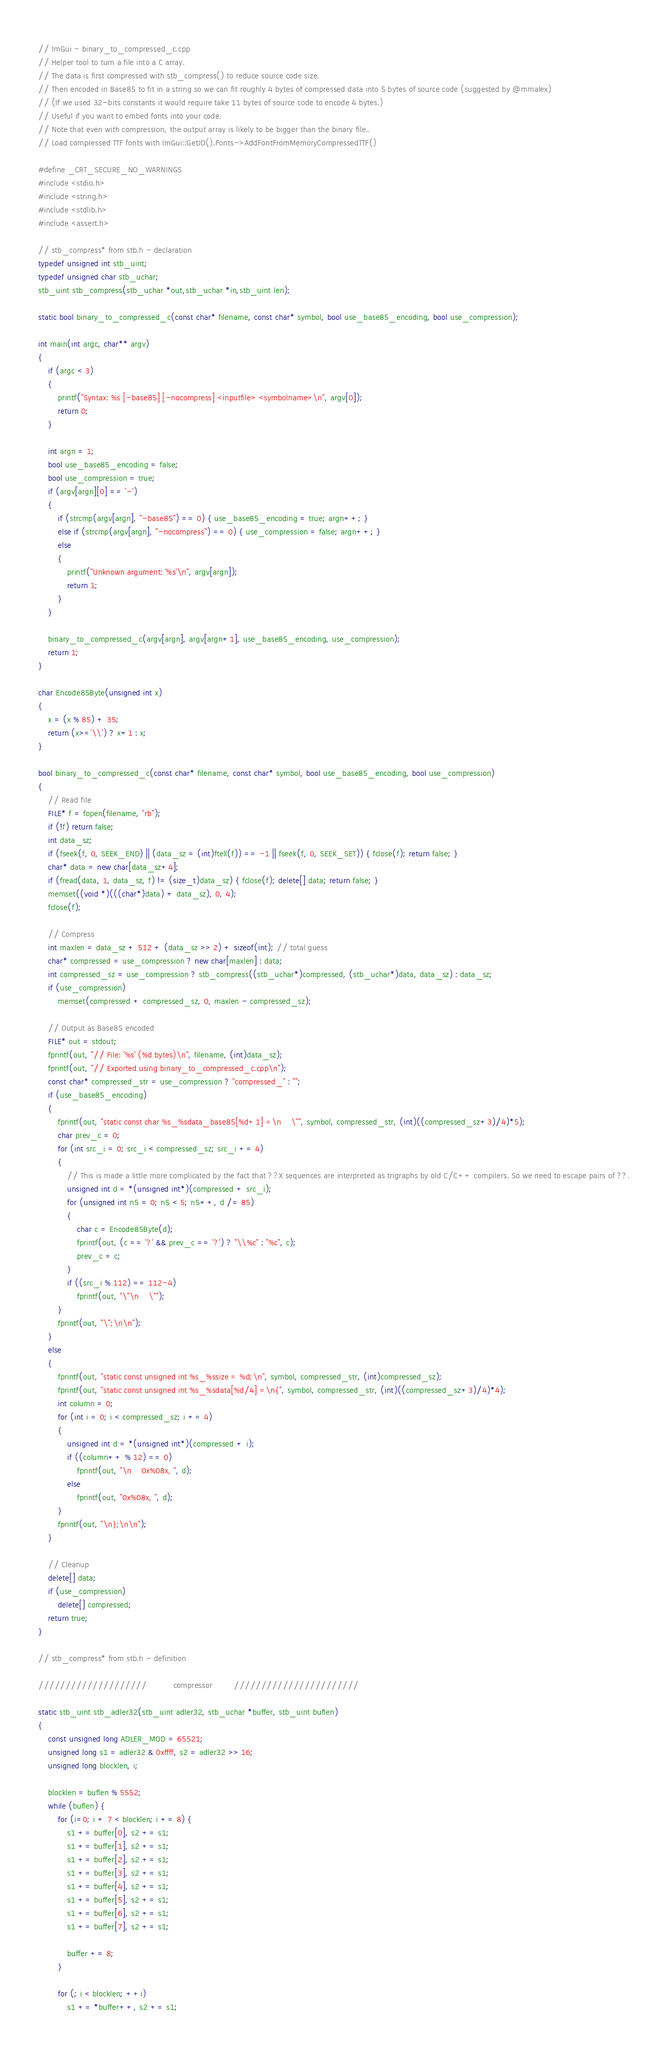Convert code to text. <code><loc_0><loc_0><loc_500><loc_500><_C++_>// ImGui - binary_to_compressed_c.cpp
// Helper tool to turn a file into a C array.
// The data is first compressed with stb_compress() to reduce source code size.
// Then encoded in Base85 to fit in a string so we can fit roughly 4 bytes of compressed data into 5 bytes of source code (suggested by @mmalex)
// (If we used 32-bits constants it would require take 11 bytes of source code to encode 4 bytes.)
// Useful if you want to embed fonts into your code.
// Note that even with compression, the output array is likely to be bigger than the binary file..
// Load compressed TTF fonts with ImGui::GetIO().Fonts->AddFontFromMemoryCompressedTTF()

#define _CRT_SECURE_NO_WARNINGS
#include <stdio.h>
#include <string.h>
#include <stdlib.h>
#include <assert.h>

// stb_compress* from stb.h - declaration
typedef unsigned int stb_uint;
typedef unsigned char stb_uchar;
stb_uint stb_compress(stb_uchar *out,stb_uchar *in,stb_uint len);

static bool binary_to_compressed_c(const char* filename, const char* symbol, bool use_base85_encoding, bool use_compression);

int main(int argc, char** argv)
{
    if (argc < 3)
    {
        printf("Syntax: %s [-base85] [-nocompress] <inputfile> <symbolname>\n", argv[0]);
        return 0;
    }

    int argn = 1;
    bool use_base85_encoding = false;
    bool use_compression = true;
    if (argv[argn][0] == '-')
    {
        if (strcmp(argv[argn], "-base85") == 0) { use_base85_encoding = true; argn++; }
        else if (strcmp(argv[argn], "-nocompress") == 0) { use_compression = false; argn++; }
        else
        {
            printf("Unknown argument: '%s'\n", argv[argn]);
            return 1;
        }
    }

    binary_to_compressed_c(argv[argn], argv[argn+1], use_base85_encoding, use_compression);
    return 1;
}

char Encode85Byte(unsigned int x) 
{
    x = (x % 85) + 35;
    return (x>='\\') ? x+1 : x;
}

bool binary_to_compressed_c(const char* filename, const char* symbol, bool use_base85_encoding, bool use_compression)
{
    // Read file
    FILE* f = fopen(filename, "rb");
    if (!f) return false;
    int data_sz;
    if (fseek(f, 0, SEEK_END) || (data_sz = (int)ftell(f)) == -1 || fseek(f, 0, SEEK_SET)) { fclose(f); return false; }
    char* data = new char[data_sz+4];
    if (fread(data, 1, data_sz, f) != (size_t)data_sz) { fclose(f); delete[] data; return false; }
    memset((void *)(((char*)data) + data_sz), 0, 4);
    fclose(f);

    // Compress
    int maxlen = data_sz + 512 + (data_sz >> 2) + sizeof(int); // total guess
    char* compressed = use_compression ? new char[maxlen] : data;
    int compressed_sz = use_compression ? stb_compress((stb_uchar*)compressed, (stb_uchar*)data, data_sz) : data_sz;
    if (use_compression)
		memset(compressed + compressed_sz, 0, maxlen - compressed_sz);

    // Output as Base85 encoded
    FILE* out = stdout;
    fprintf(out, "// File: '%s' (%d bytes)\n", filename, (int)data_sz);
    fprintf(out, "// Exported using binary_to_compressed_c.cpp\n");
	const char* compressed_str = use_compression ? "compressed_" : "";
    if (use_base85_encoding)
    {
        fprintf(out, "static const char %s_%sdata_base85[%d+1] =\n    \"", symbol, compressed_str, (int)((compressed_sz+3)/4)*5);
        char prev_c = 0;
        for (int src_i = 0; src_i < compressed_sz; src_i += 4)
        {
            // This is made a little more complicated by the fact that ??X sequences are interpreted as trigraphs by old C/C++ compilers. So we need to escape pairs of ??.
            unsigned int d = *(unsigned int*)(compressed + src_i);
            for (unsigned int n5 = 0; n5 < 5; n5++, d /= 85)
            {
                char c = Encode85Byte(d);
                fprintf(out, (c == '?' && prev_c == '?') ? "\\%c" : "%c", c);
                prev_c = c;
            }
            if ((src_i % 112) == 112-4)
                fprintf(out, "\"\n    \"");
        }
        fprintf(out, "\";\n\n");
    }
    else
    {
        fprintf(out, "static const unsigned int %s_%ssize = %d;\n", symbol, compressed_str, (int)compressed_sz);
        fprintf(out, "static const unsigned int %s_%sdata[%d/4] =\n{", symbol, compressed_str, (int)((compressed_sz+3)/4)*4);
        int column = 0;
        for (int i = 0; i < compressed_sz; i += 4)
        {
            unsigned int d = *(unsigned int*)(compressed + i);
            if ((column++ % 12) == 0)
                fprintf(out, "\n    0x%08x, ", d);
            else
                fprintf(out, "0x%08x, ", d);
        }
        fprintf(out, "\n};\n\n");
    }

    // Cleanup
    delete[] data;
    if (use_compression)
	    delete[] compressed;
    return true;
}

// stb_compress* from stb.h - definition

////////////////////           compressor         ///////////////////////

static stb_uint stb_adler32(stb_uint adler32, stb_uchar *buffer, stb_uint buflen)
{
    const unsigned long ADLER_MOD = 65521;
    unsigned long s1 = adler32 & 0xffff, s2 = adler32 >> 16;
    unsigned long blocklen, i;

    blocklen = buflen % 5552;
    while (buflen) {
        for (i=0; i + 7 < blocklen; i += 8) {
            s1 += buffer[0], s2 += s1;
            s1 += buffer[1], s2 += s1;
            s1 += buffer[2], s2 += s1;
            s1 += buffer[3], s2 += s1;
            s1 += buffer[4], s2 += s1;
            s1 += buffer[5], s2 += s1;
            s1 += buffer[6], s2 += s1;
            s1 += buffer[7], s2 += s1;

            buffer += 8;
        }

        for (; i < blocklen; ++i)
            s1 += *buffer++, s2 += s1;
</code> 